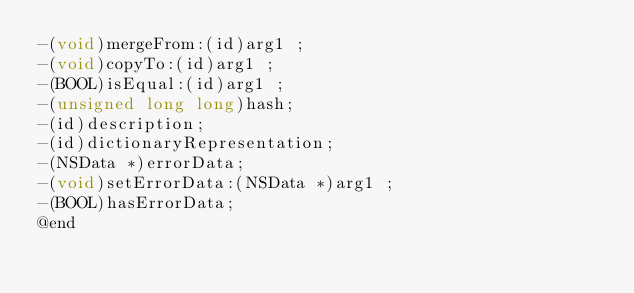<code> <loc_0><loc_0><loc_500><loc_500><_C_>-(void)mergeFrom:(id)arg1 ;
-(void)copyTo:(id)arg1 ;
-(BOOL)isEqual:(id)arg1 ;
-(unsigned long long)hash;
-(id)description;
-(id)dictionaryRepresentation;
-(NSData *)errorData;
-(void)setErrorData:(NSData *)arg1 ;
-(BOOL)hasErrorData;
@end

</code> 